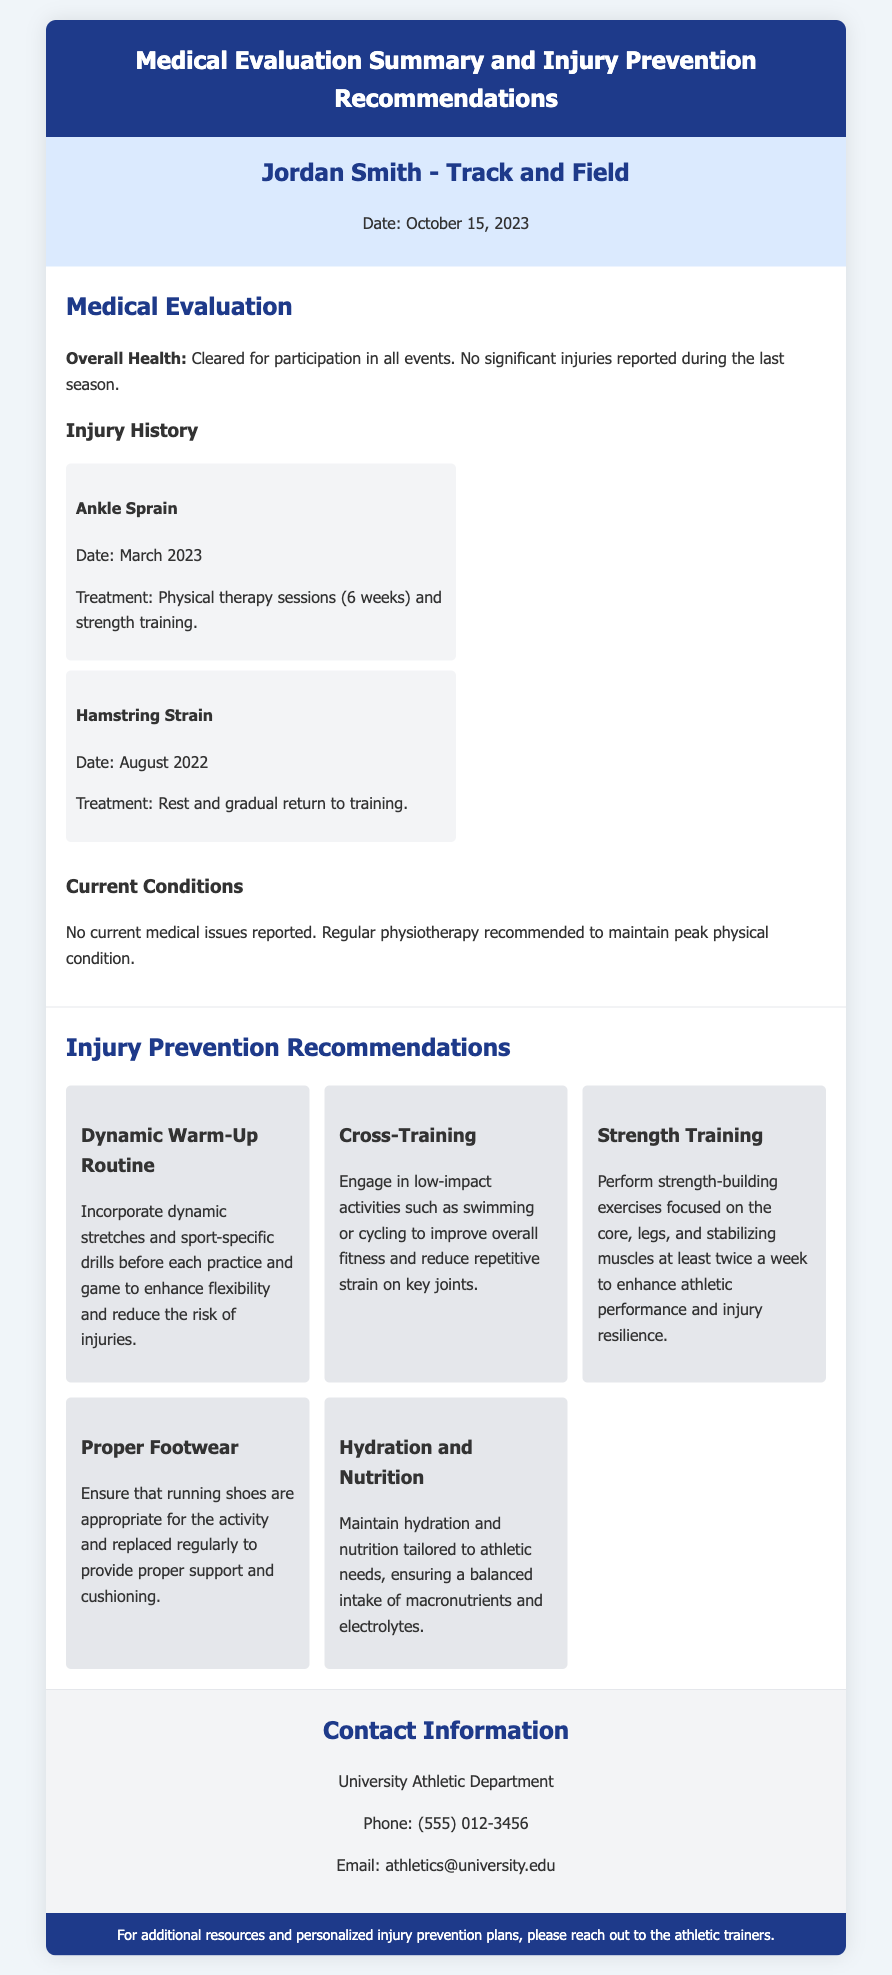What is the athlete's name? The athlete's name is listed at the top of the document under athlete info.
Answer: Jordan Smith What is the date of the medical evaluation? The date is provided in the athlete info section of the document.
Answer: October 15, 2023 What injury did the athlete sustain in March 2023? The document mentions the specific type of injury in the injury history section.
Answer: Ankle Sprain How many weeks of physical therapy were prescribed for the ankle sprain? The duration of the treatment is stated in the injury history section.
Answer: 6 weeks What is one recommendation for improving overall fitness? The recommendations section lists activities to enhance fitness and reduce strain.
Answer: Cross-Training How often should strength-building exercises be performed? The document specifies the frequency of strength training in the recommendations section.
Answer: At least twice a week Who should you contact for additional resources? The contact information section provides the department to reach out to.
Answer: University Athletic Department What is one key aspect of the dynamic warm-up routine? The recommendations section specifies what to include in the warm-up.
Answer: Dynamic stretches What type of condition is the athlete currently in? The current condition of the athlete is stated clearly in the medical evaluation section.
Answer: No current medical issues reported 